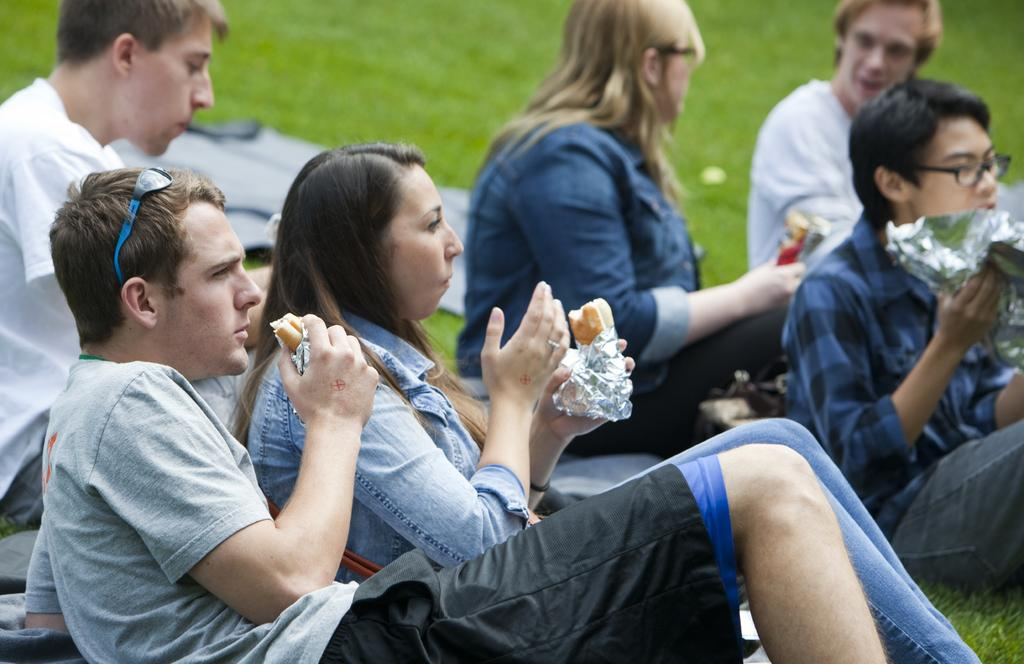Who is present in the image? There are people in the image. What are the people doing in the image? The people are sitting on the grass and eating food. What type of fear can be seen on the people's faces in the image? There is no indication of fear on the people's faces in the image; they appear to be enjoying themselves while sitting on the grass and eating food. 